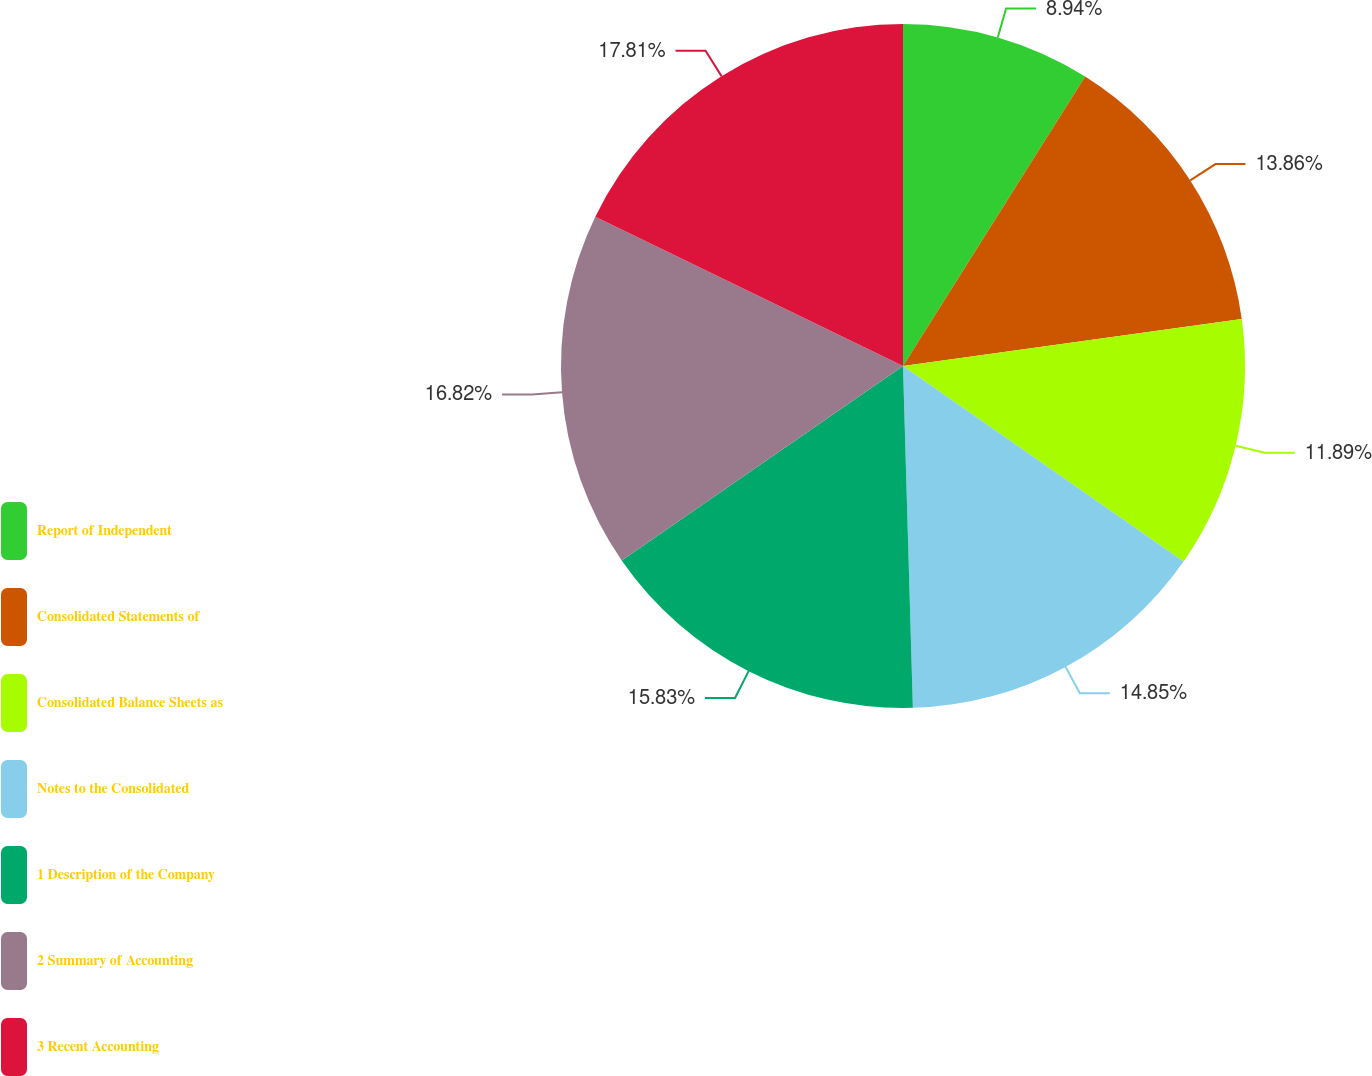Convert chart to OTSL. <chart><loc_0><loc_0><loc_500><loc_500><pie_chart><fcel>Report of Independent<fcel>Consolidated Statements of<fcel>Consolidated Balance Sheets as<fcel>Notes to the Consolidated<fcel>1 Description of the Company<fcel>2 Summary of Accounting<fcel>3 Recent Accounting<nl><fcel>8.94%<fcel>13.86%<fcel>11.89%<fcel>14.85%<fcel>15.83%<fcel>16.82%<fcel>17.81%<nl></chart> 